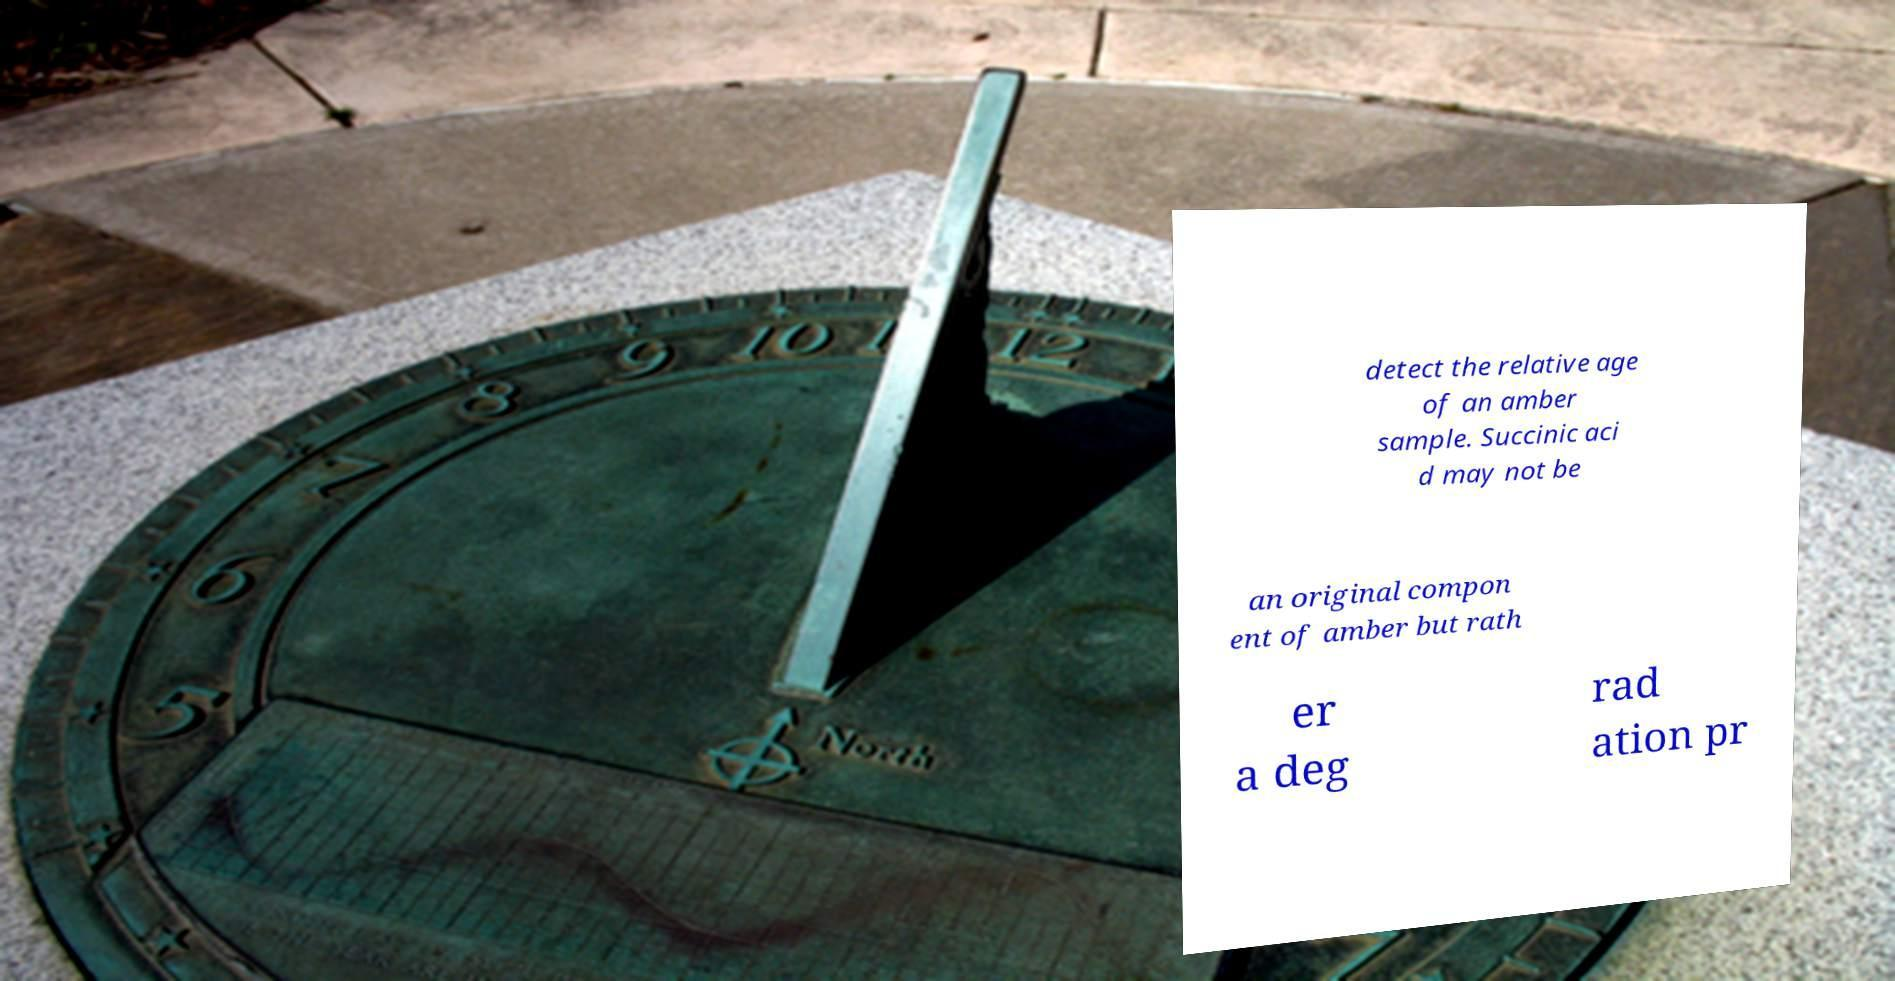Please read and relay the text visible in this image. What does it say? detect the relative age of an amber sample. Succinic aci d may not be an original compon ent of amber but rath er a deg rad ation pr 